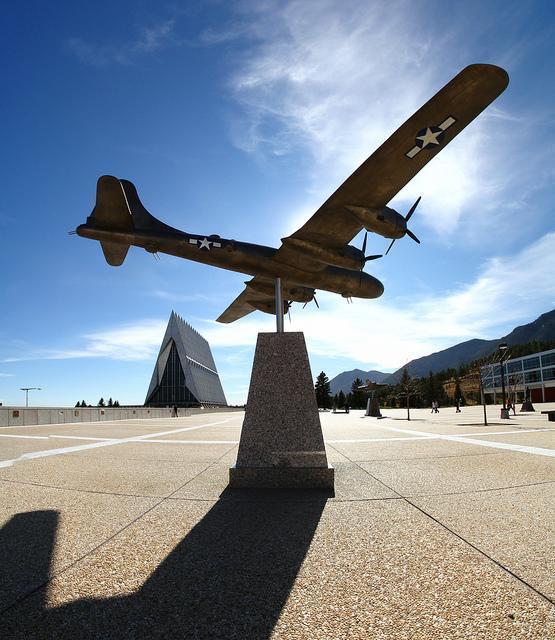How fast is this plane flying now?
Make your selection from the four choices given to correctly answer the question.
Options: Zero mph, 100 mph, mach 5, 250 mph. Zero mph. 